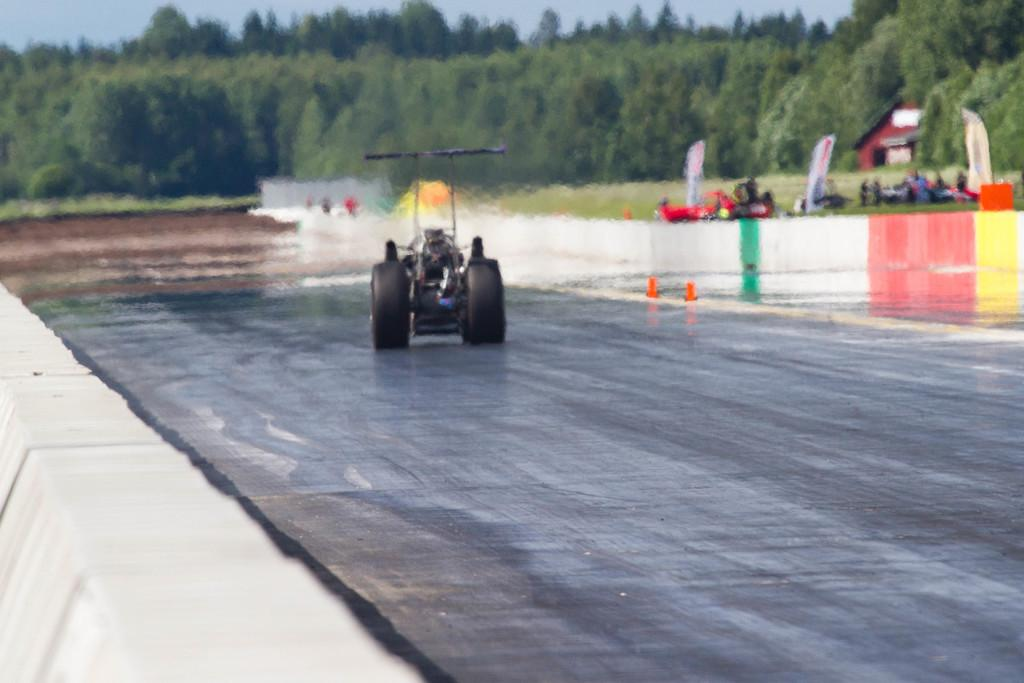What is the main subject in the middle of the image? There is a vehicle in the middle of the image. What else can be seen on the right side of the image? There are other vehicles on the right side of the image. What type of structure is present in the image? There is a house in the image. What can be seen in the background of the image? There are trees in the background of the image. What is visible at the top of the image? The sky is visible at the top of the image. What type of meal is being prepared in the image? There is no meal preparation visible in the image. Can you see any hooks in the image? There are no hooks present in the image. 